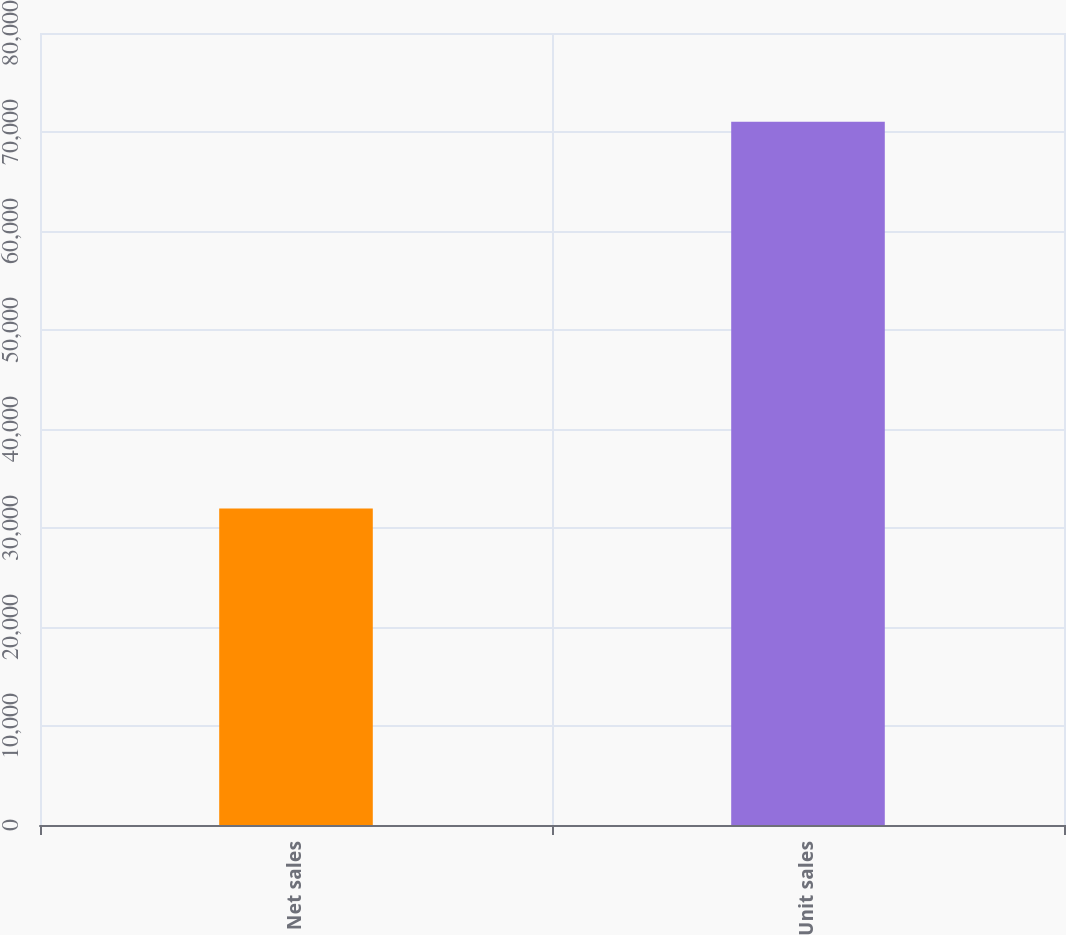Convert chart. <chart><loc_0><loc_0><loc_500><loc_500><bar_chart><fcel>Net sales<fcel>Unit sales<nl><fcel>31980<fcel>71033<nl></chart> 